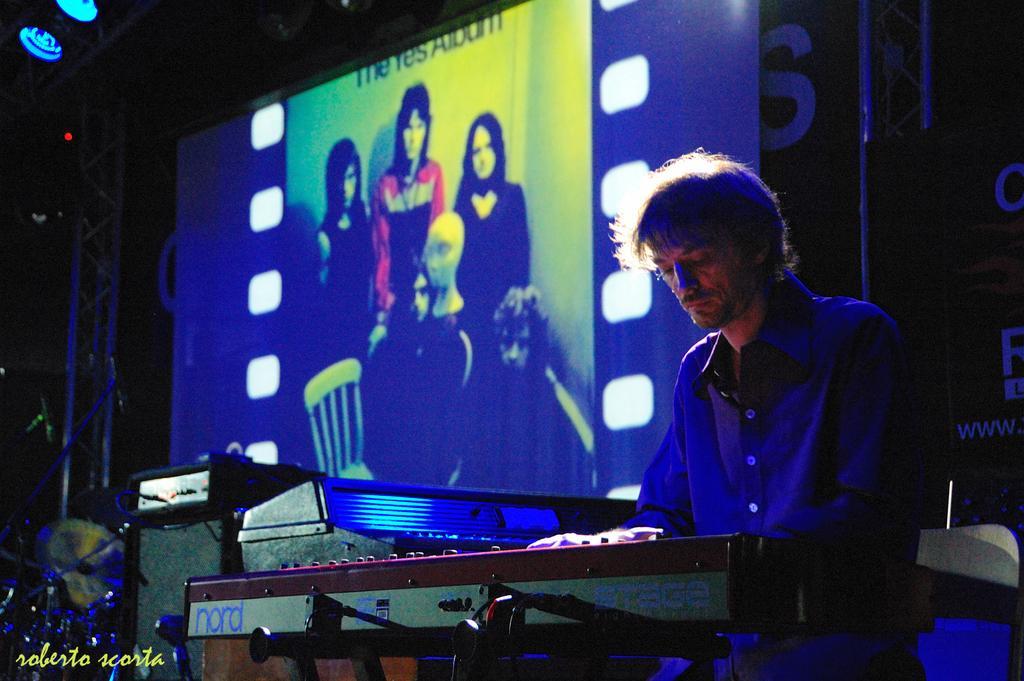Could you give a brief overview of what you see in this image? In this image I can see a person is playing a musical instrument. In the background I can see a screen, metal rod and a roof top. This image is taken on the stage during night. 